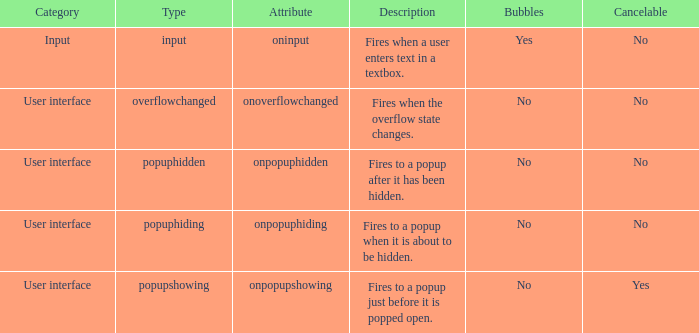What's the bubbles with attribute being onpopuphidden No. 